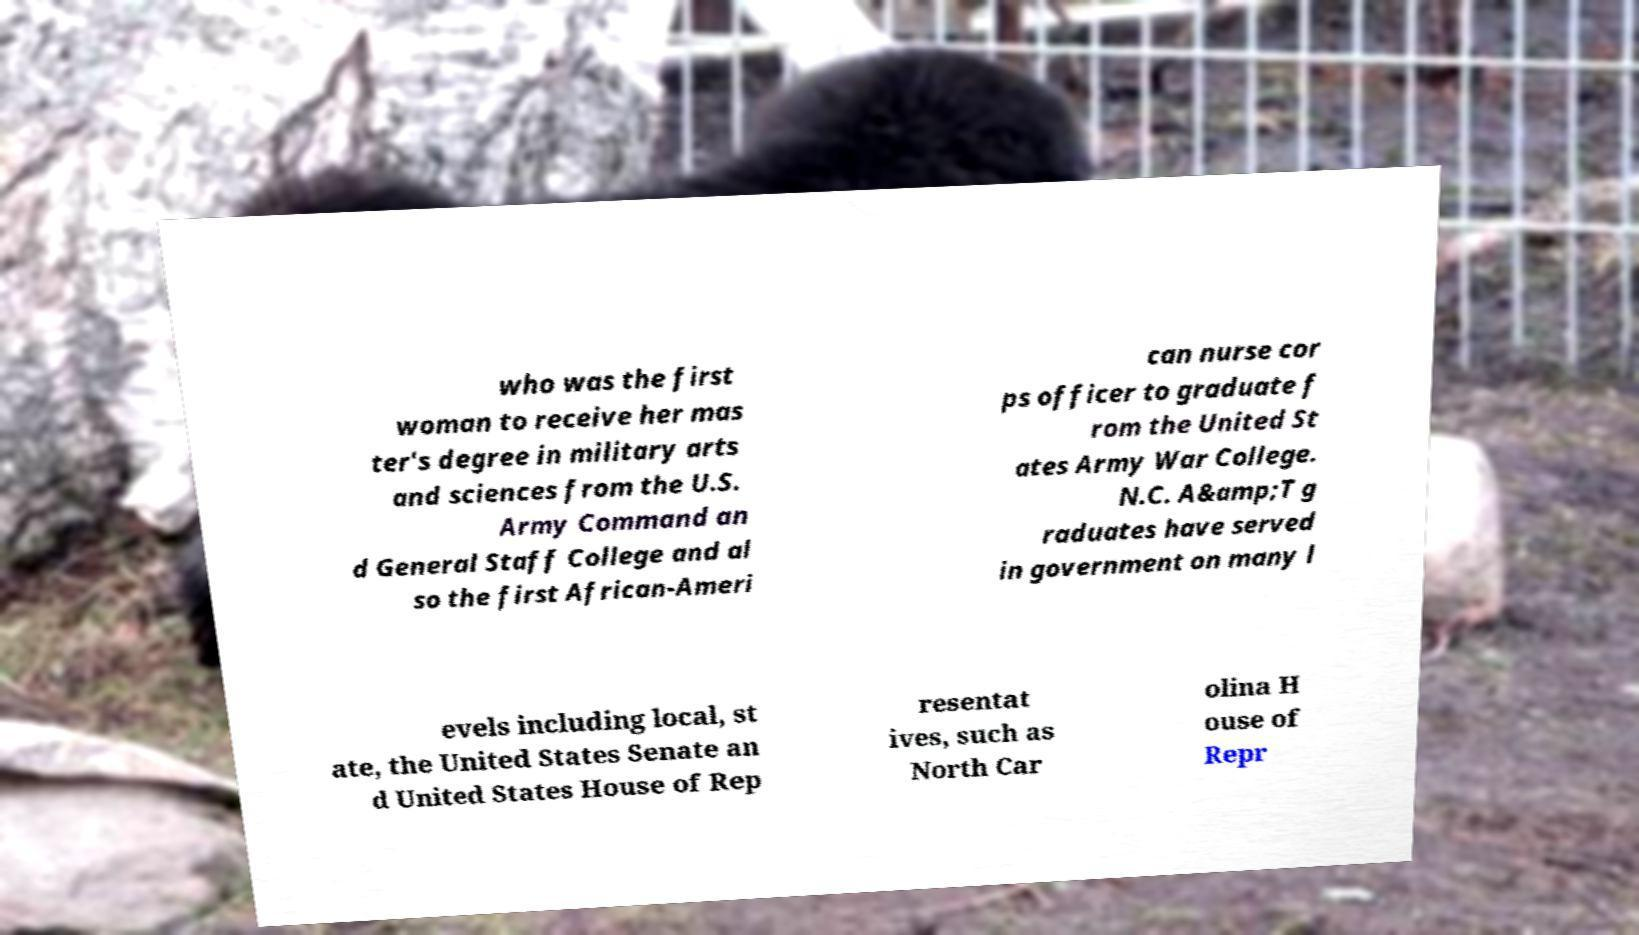What messages or text are displayed in this image? I need them in a readable, typed format. who was the first woman to receive her mas ter's degree in military arts and sciences from the U.S. Army Command an d General Staff College and al so the first African-Ameri can nurse cor ps officer to graduate f rom the United St ates Army War College. N.C. A&amp;T g raduates have served in government on many l evels including local, st ate, the United States Senate an d United States House of Rep resentat ives, such as North Car olina H ouse of Repr 